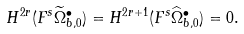<formula> <loc_0><loc_0><loc_500><loc_500>H ^ { 2 r } ( F ^ { s } \widetilde { \Omega } ^ { \bullet } _ { b , 0 } ) = H ^ { 2 r + 1 } ( F ^ { s } \widehat { \Omega } ^ { \bullet } _ { b , 0 } ) = 0 .</formula> 